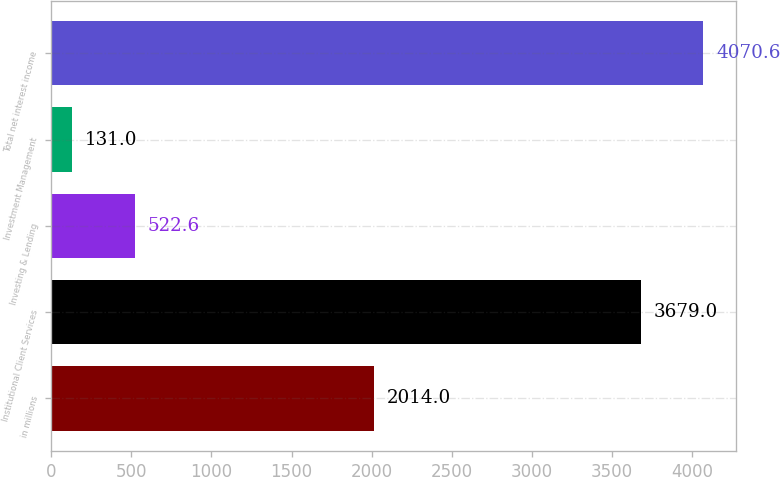<chart> <loc_0><loc_0><loc_500><loc_500><bar_chart><fcel>in millions<fcel>Institutional Client Services<fcel>Investing & Lending<fcel>Investment Management<fcel>Total net interest income<nl><fcel>2014<fcel>3679<fcel>522.6<fcel>131<fcel>4070.6<nl></chart> 